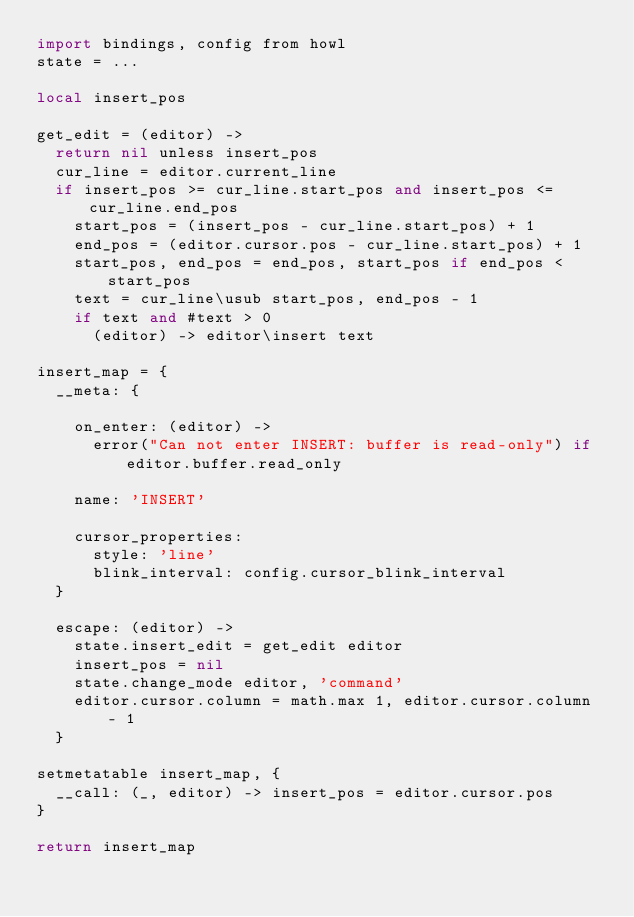<code> <loc_0><loc_0><loc_500><loc_500><_MoonScript_>import bindings, config from howl
state = ...

local insert_pos

get_edit = (editor) ->
  return nil unless insert_pos
  cur_line = editor.current_line
  if insert_pos >= cur_line.start_pos and insert_pos <= cur_line.end_pos
    start_pos = (insert_pos - cur_line.start_pos) + 1
    end_pos = (editor.cursor.pos - cur_line.start_pos) + 1
    start_pos, end_pos = end_pos, start_pos if end_pos < start_pos
    text = cur_line\usub start_pos, end_pos - 1
    if text and #text > 0
      (editor) -> editor\insert text

insert_map = {
  __meta: {

    on_enter: (editor) ->
      error("Can not enter INSERT: buffer is read-only") if editor.buffer.read_only

    name: 'INSERT'

    cursor_properties:
      style: 'line'
      blink_interval: config.cursor_blink_interval
  }

  escape: (editor) ->
    state.insert_edit = get_edit editor
    insert_pos = nil
    state.change_mode editor, 'command'
    editor.cursor.column = math.max 1, editor.cursor.column - 1
  }

setmetatable insert_map, {
  __call: (_, editor) -> insert_pos = editor.cursor.pos
}

return insert_map
</code> 